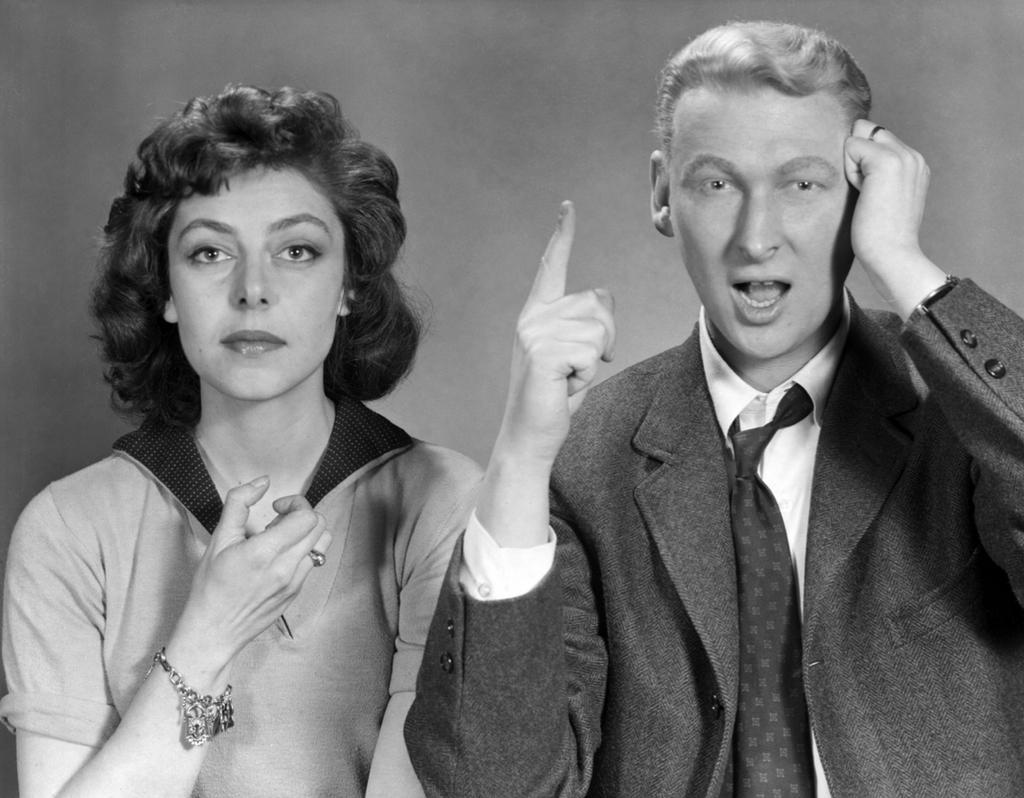In one or two sentences, can you explain what this image depicts? This picture shows a woman and a man and we see man wore a coat and tie. 